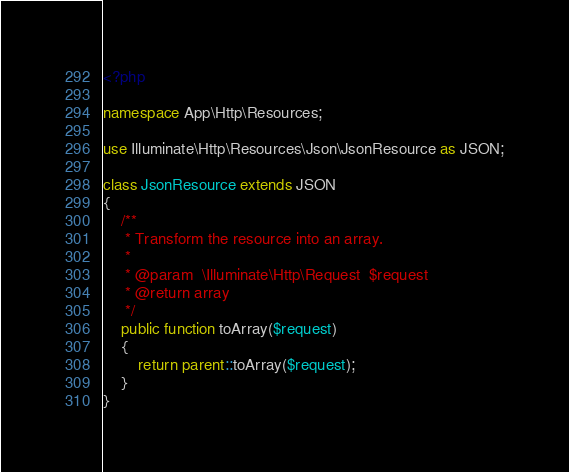Convert code to text. <code><loc_0><loc_0><loc_500><loc_500><_PHP_><?php

namespace App\Http\Resources;

use Illuminate\Http\Resources\Json\JsonResource as JSON;

class JsonResource extends JSON
{
    /**
     * Transform the resource into an array.
     *
     * @param  \Illuminate\Http\Request  $request
     * @return array
     */
    public function toArray($request)
    {
        return parent::toArray($request);
    }
}
</code> 